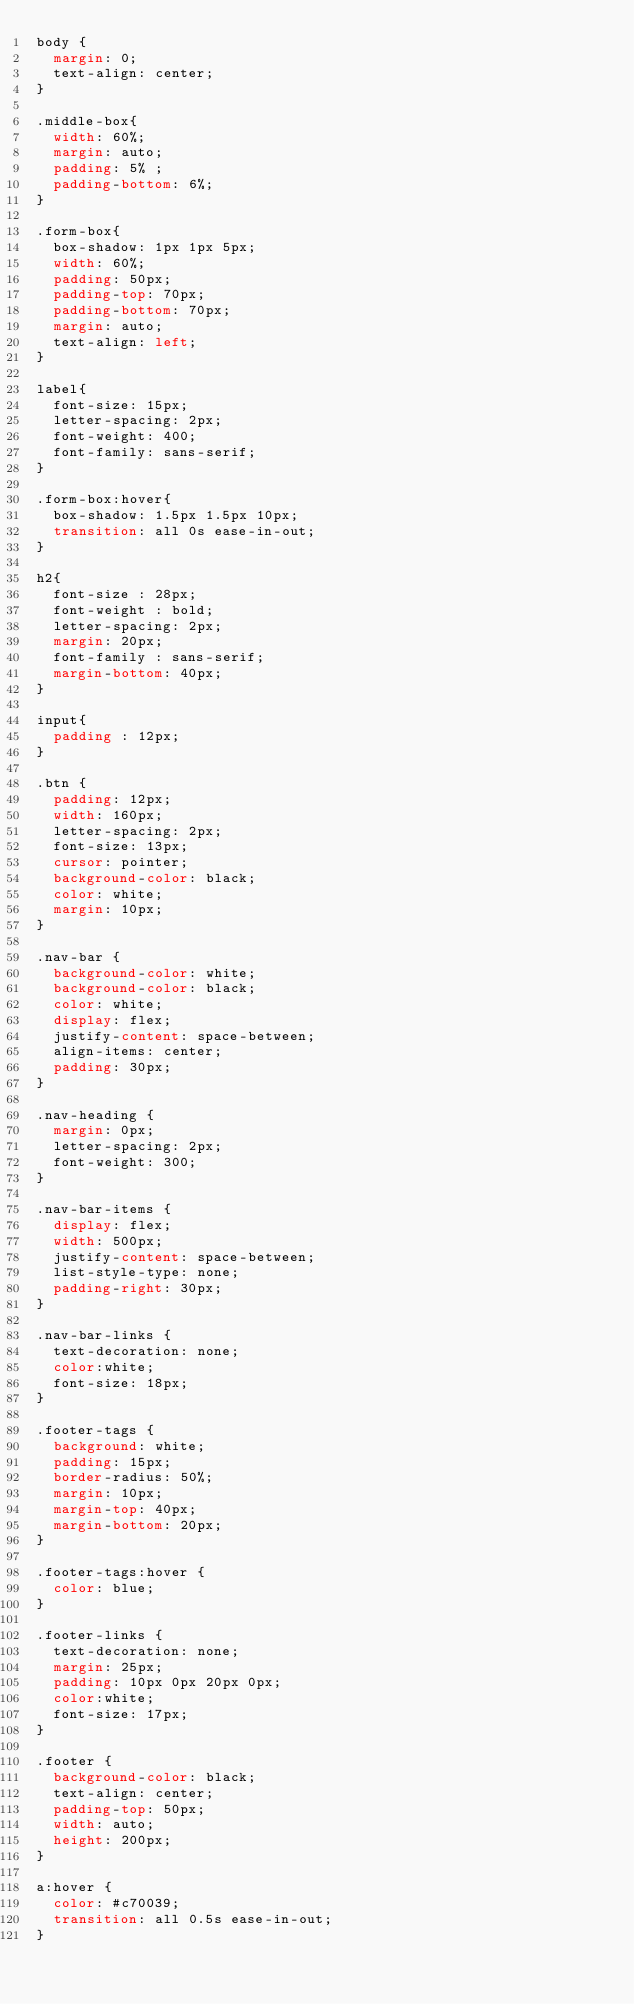Convert code to text. <code><loc_0><loc_0><loc_500><loc_500><_CSS_>body {
  margin: 0;
  text-align: center;
}

.middle-box{
  width: 60%;
  margin: auto;
  padding: 5% ;
  padding-bottom: 6%;
}

.form-box{
  box-shadow: 1px 1px 5px;
  width: 60%;
  padding: 50px;
  padding-top: 70px;
  padding-bottom: 70px;
  margin: auto;
  text-align: left;
}

label{
  font-size: 15px;
  letter-spacing: 2px;
  font-weight: 400;
  font-family: sans-serif;
}

.form-box:hover{
  box-shadow: 1.5px 1.5px 10px;
  transition: all 0s ease-in-out;
}

h2{
  font-size : 28px;
  font-weight : bold;
  letter-spacing: 2px;
  margin: 20px;
  font-family : sans-serif;
  margin-bottom: 40px;
}

input{
  padding : 12px;
}

.btn {
  padding: 12px;
  width: 160px;
  letter-spacing: 2px;
  font-size: 13px;
  cursor: pointer;
  background-color: black;
  color: white;
  margin: 10px;
}

.nav-bar {
  background-color: white;
  background-color: black;
  color: white;
  display: flex;
  justify-content: space-between;
  align-items: center;
  padding: 30px;
}

.nav-heading {
  margin: 0px;
  letter-spacing: 2px;
  font-weight: 300;
}

.nav-bar-items {
  display: flex;
  width: 500px;
  justify-content: space-between;
  list-style-type: none;
  padding-right: 30px;
}

.nav-bar-links {
  text-decoration: none;
  color:white;
  font-size: 18px;
}

.footer-tags {
  background: white;
  padding: 15px;
  border-radius: 50%;
  margin: 10px;
  margin-top: 40px;
  margin-bottom: 20px;
}

.footer-tags:hover {
  color: blue;
}

.footer-links {
  text-decoration: none;
  margin: 25px;
  padding: 10px 0px 20px 0px;
  color:white;
  font-size: 17px;
}

.footer {
  background-color: black;
  text-align: center;
  padding-top: 50px;
  width: auto;
  height: 200px;
}

a:hover {
  color: #c70039;
  transition: all 0.5s ease-in-out;
}
</code> 